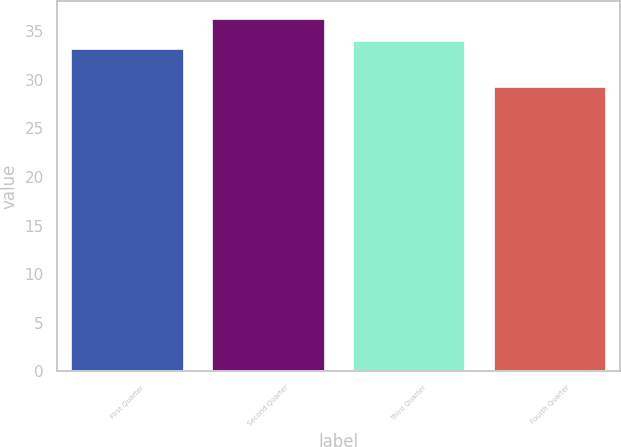Convert chart to OTSL. <chart><loc_0><loc_0><loc_500><loc_500><bar_chart><fcel>First Quarter<fcel>Second Quarter<fcel>Third Quarter<fcel>Fourth Quarter<nl><fcel>33.18<fcel>36.29<fcel>34.02<fcel>29.23<nl></chart> 